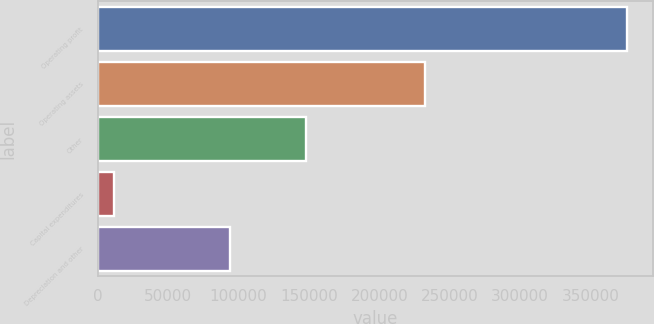Convert chart to OTSL. <chart><loc_0><loc_0><loc_500><loc_500><bar_chart><fcel>Operating profit<fcel>Operating assets<fcel>Other<fcel>Capital expenditures<fcel>Depreciation and other<nl><fcel>375867<fcel>232380<fcel>147529<fcel>11430<fcel>93683<nl></chart> 